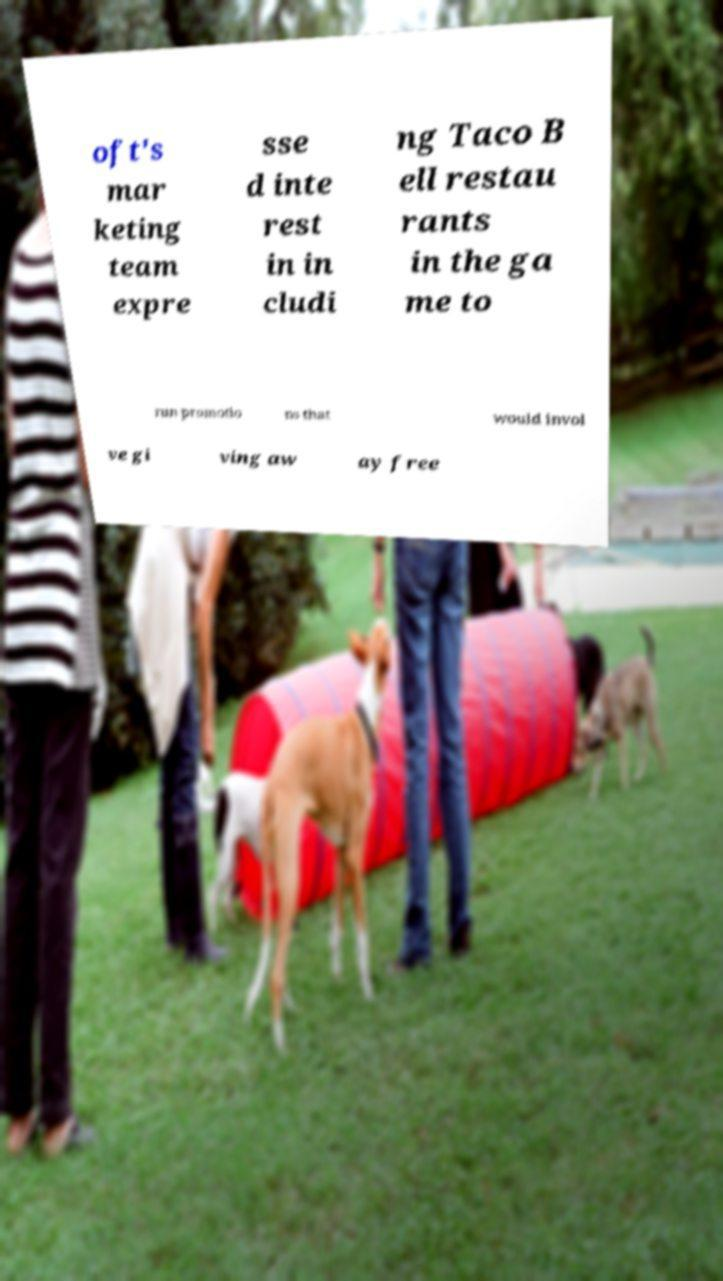Could you extract and type out the text from this image? oft's mar keting team expre sse d inte rest in in cludi ng Taco B ell restau rants in the ga me to run promotio ns that would invol ve gi ving aw ay free 